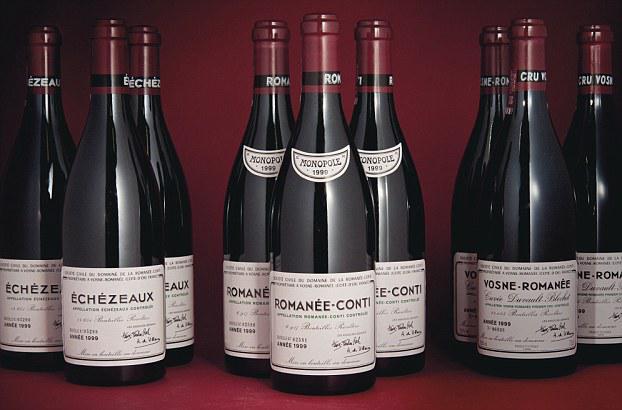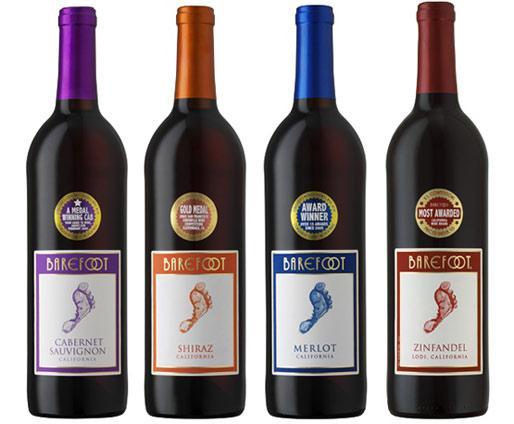The first image is the image on the left, the second image is the image on the right. Examine the images to the left and right. Is the description "Exactly three bottles are displayed in a level row with none of them touching or overlapping." accurate? Answer yes or no. No. The first image is the image on the left, the second image is the image on the right. Considering the images on both sides, is "The left image contains exactly four bottles of wine." valid? Answer yes or no. No. 